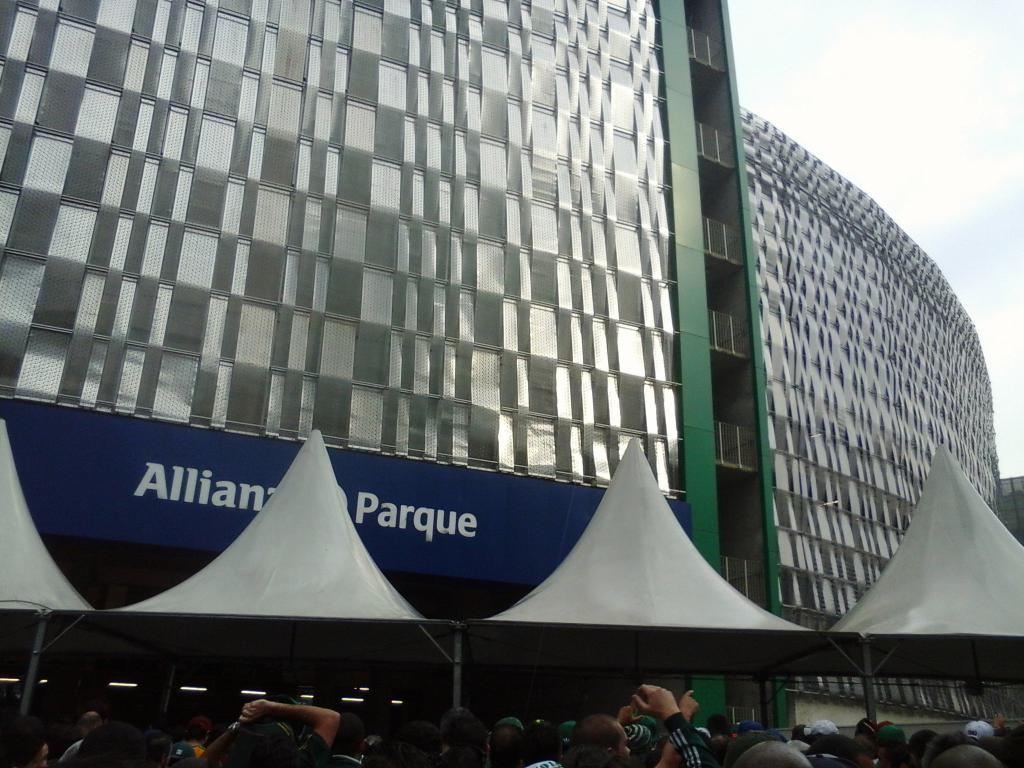What can be seen in the image? There are people standing in the image, along with a building. What is visible in the background of the image? The sky is visible in the image. How many mice are sitting on the pan in the image? There are no mice or pans present in the image. 